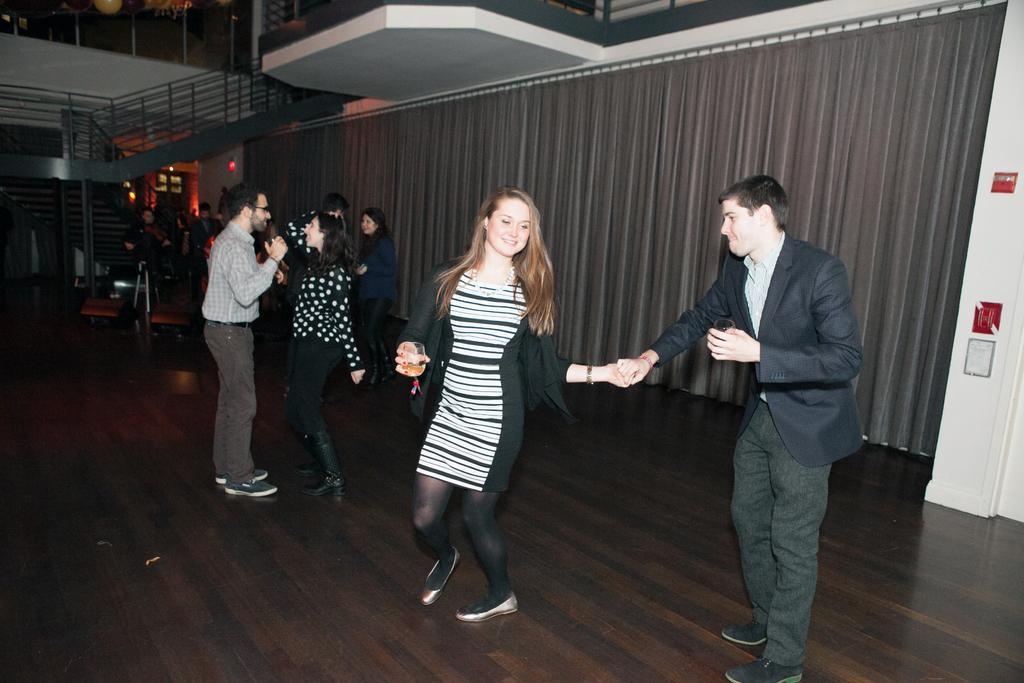How would you summarize this image in a sentence or two? In this picture we can see there are groups of people dancing on the floor. A woman is holding a glass. Behind the people, there are curtains and lights. On the right side of the image, there are some objects on the wall. On the left side of the image, there is a staircase. At the top of the image, there are some other objects. 